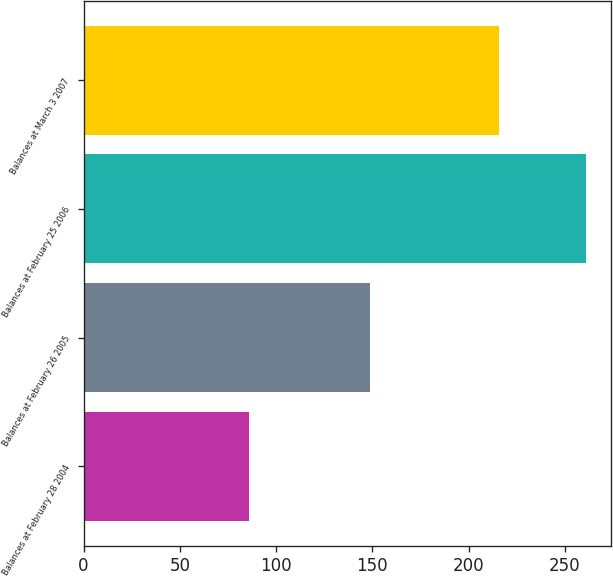Convert chart to OTSL. <chart><loc_0><loc_0><loc_500><loc_500><bar_chart><fcel>Balances at February 28 2004<fcel>Balances at February 26 2005<fcel>Balances at February 25 2006<fcel>Balances at March 3 2007<nl><fcel>86<fcel>149<fcel>261<fcel>216<nl></chart> 